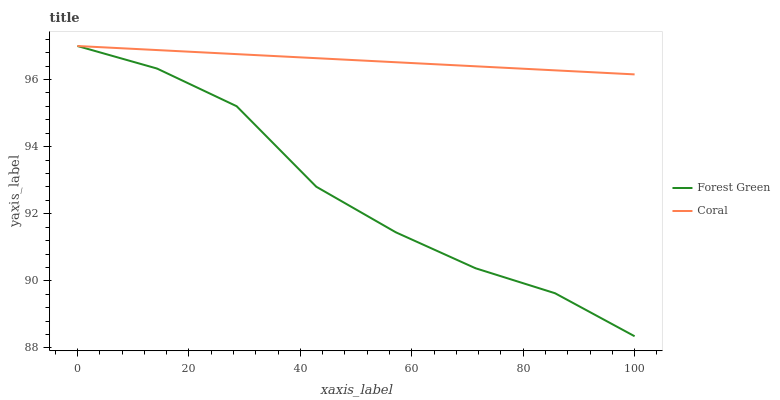Does Forest Green have the minimum area under the curve?
Answer yes or no. Yes. Does Coral have the maximum area under the curve?
Answer yes or no. Yes. Does Coral have the minimum area under the curve?
Answer yes or no. No. Is Coral the smoothest?
Answer yes or no. Yes. Is Forest Green the roughest?
Answer yes or no. Yes. Is Coral the roughest?
Answer yes or no. No. Does Forest Green have the lowest value?
Answer yes or no. Yes. Does Coral have the lowest value?
Answer yes or no. No. Does Coral have the highest value?
Answer yes or no. Yes. Does Coral intersect Forest Green?
Answer yes or no. Yes. Is Coral less than Forest Green?
Answer yes or no. No. Is Coral greater than Forest Green?
Answer yes or no. No. 